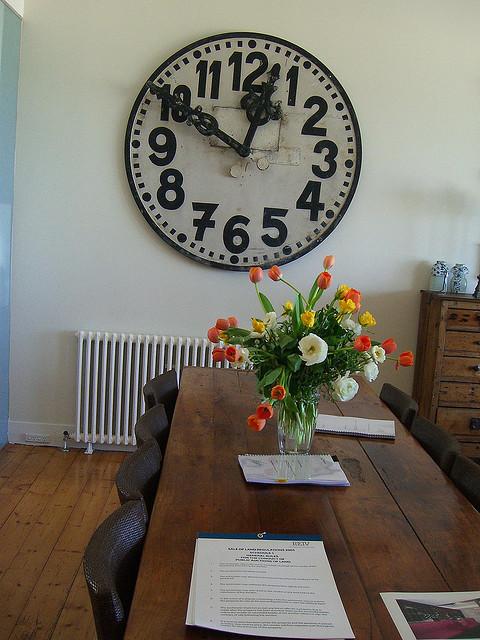Are the flowers real?
Quick response, please. Yes. How many plants are in the photo?
Short answer required. 1. What time is it?
Short answer required. 12:50. What object is against the wall under the clock?
Give a very brief answer. Radiator. What type of martial is the clock on?
Give a very brief answer. Wall. How many flowers are in the bottle?
Answer briefly. 30. 